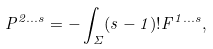<formula> <loc_0><loc_0><loc_500><loc_500>P ^ { 2 \dots s } = - \int _ { \Sigma } ( s - 1 ) ! F ^ { 1 \dots s } ,</formula> 